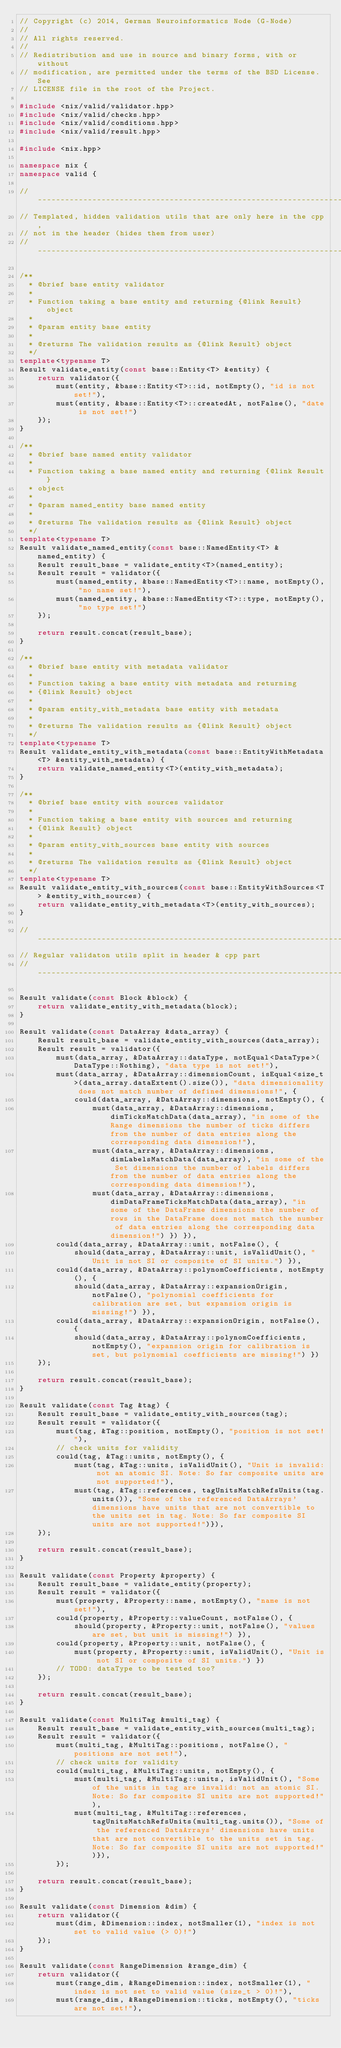Convert code to text. <code><loc_0><loc_0><loc_500><loc_500><_C++_>// Copyright (c) 2014, German Neuroinformatics Node (G-Node)
//
// All rights reserved.
//
// Redistribution and use in source and binary forms, with or without
// modification, are permitted under the terms of the BSD License. See
// LICENSE file in the root of the Project.

#include <nix/valid/validator.hpp>
#include <nix/valid/checks.hpp>
#include <nix/valid/conditions.hpp>
#include <nix/valid/result.hpp>

#include <nix.hpp>

namespace nix {
namespace valid {

// ---------------------------------------------------------------------
// Templated, hidden validation utils that are only here in the cpp,
// not in the header (hides them from user)
// ---------------------------------------------------------------------

/**
  * @brief base entity validator
  *
  * Function taking a base entity and returning {@link Result} object
  *
  * @param entity base entity
  *
  * @returns The validation results as {@link Result} object
  */
template<typename T>
Result validate_entity(const base::Entity<T> &entity) {
    return validator({
        must(entity, &base::Entity<T>::id, notEmpty(), "id is not set!"),
        must(entity, &base::Entity<T>::createdAt, notFalse(), "date is not set!")
    });
}

/**
  * @brief base named entity validator
  *
  * Function taking a base named entity and returning {@link Result}
  * object
  *
  * @param named_entity base named entity
  *
  * @returns The validation results as {@link Result} object
  */
template<typename T>
Result validate_named_entity(const base::NamedEntity<T> &named_entity) {
    Result result_base = validate_entity<T>(named_entity);
    Result result = validator({
        must(named_entity, &base::NamedEntity<T>::name, notEmpty(), "no name set!"),
        must(named_entity, &base::NamedEntity<T>::type, notEmpty(), "no type set!")
    });

    return result.concat(result_base);
}

/**
  * @brief base entity with metadata validator
  *
  * Function taking a base entity with metadata and returning
  * {@link Result} object
  *
  * @param entity_with_metadata base entity with metadata
  *
  * @returns The validation results as {@link Result} object
  */
template<typename T>
Result validate_entity_with_metadata(const base::EntityWithMetadata<T> &entity_with_metadata) {
    return validate_named_entity<T>(entity_with_metadata);
}

/**
  * @brief base entity with sources validator
  *
  * Function taking a base entity with sources and returning
  * {@link Result} object
  *
  * @param entity_with_sources base entity with sources
  *
  * @returns The validation results as {@link Result} object
  */
template<typename T>
Result validate_entity_with_sources(const base::EntityWithSources<T> &entity_with_sources) {
    return validate_entity_with_metadata<T>(entity_with_sources);
}

// ---------------------------------------------------------------------
// Regular validaton utils split in header & cpp part
// ---------------------------------------------------------------------

Result validate(const Block &block) {
    return validate_entity_with_metadata(block);
}

Result validate(const DataArray &data_array) {
    Result result_base = validate_entity_with_sources(data_array);
    Result result = validator({
        must(data_array, &DataArray::dataType, notEqual<DataType>(DataType::Nothing), "data type is not set!"),
        must(data_array, &DataArray::dimensionCount, isEqual<size_t>(data_array.dataExtent().size()), "data dimensionality does not match number of defined dimensions!", {
            could(data_array, &DataArray::dimensions, notEmpty(), {
                must(data_array, &DataArray::dimensions, dimTicksMatchData(data_array), "in some of the Range dimensions the number of ticks differs from the number of data entries along the corresponding data dimension!"),
                must(data_array, &DataArray::dimensions, dimLabelsMatchData(data_array), "in some of the Set dimensions the number of labels differs from the number of data entries along the corresponding data dimension!"),
                must(data_array, &DataArray::dimensions, dimDataFrameTicksMatchData(data_array), "in some of the DataFrame dimensions the number of rows in the DataFrame does not match the number of data entries along the corresponding data dimension!") }) }),
        could(data_array, &DataArray::unit, notFalse(), {
            should(data_array, &DataArray::unit, isValidUnit(), "Unit is not SI or composite of SI units.") }),
        could(data_array, &DataArray::polynomCoefficients, notEmpty(), {
            should(data_array, &DataArray::expansionOrigin, notFalse(), "polynomial coefficients for calibration are set, but expansion origin is missing!") }),
        could(data_array, &DataArray::expansionOrigin, notFalse(), {
            should(data_array, &DataArray::polynomCoefficients, notEmpty(), "expansion origin for calibration is set, but polynomial coefficients are missing!") })
    });

    return result.concat(result_base);
}

Result validate(const Tag &tag) {
    Result result_base = validate_entity_with_sources(tag);
    Result result = validator({
        must(tag, &Tag::position, notEmpty(), "position is not set!"),
        // check units for validity
        could(tag, &Tag::units, notEmpty(), {
            must(tag, &Tag::units, isValidUnit(), "Unit is invalid: not an atomic SI. Note: So far composite units are not supported!"),
            must(tag, &Tag::references, tagUnitsMatchRefsUnits(tag.units()), "Some of the referenced DataArrays' dimensions have units that are not convertible to the units set in tag. Note: So far composite SI units are not supported!")}),
    });

    return result.concat(result_base);
}

Result validate(const Property &property) {
    Result result_base = validate_entity(property);
    Result result = validator({
        must(property, &Property::name, notEmpty(), "name is not set!"),
        could(property, &Property::valueCount, notFalse(), {
            should(property, &Property::unit, notFalse(), "values are set, but unit is missing!") }),
        could(property, &Property::unit, notFalse(), {
            must(property, &Property::unit, isValidUnit(), "Unit is not SI or composite of SI units.") })
        // TODO: dataType to be tested too?
    });

    return result.concat(result_base);
}

Result validate(const MultiTag &multi_tag) {
    Result result_base = validate_entity_with_sources(multi_tag);
    Result result = validator({
        must(multi_tag, &MultiTag::positions, notFalse(), "positions are not set!"),
        // check units for validity
        could(multi_tag, &MultiTag::units, notEmpty(), {
            must(multi_tag, &MultiTag::units, isValidUnit(), "Some of the units in tag are invalid: not an atomic SI. Note: So far composite SI units are not supported!"),
            must(multi_tag, &MultiTag::references, tagUnitsMatchRefsUnits(multi_tag.units()), "Some of the referenced DataArrays' dimensions have units that are not convertible to the units set in tag. Note: So far composite SI units are not supported!")}),
        });

    return result.concat(result_base);
}

Result validate(const Dimension &dim) {
    return validator({
        must(dim, &Dimension::index, notSmaller(1), "index is not set to valid value (> 0)!")
    });
}

Result validate(const RangeDimension &range_dim) {
    return validator({
        must(range_dim, &RangeDimension::index, notSmaller(1), "index is not set to valid value (size_t > 0)!"),
        must(range_dim, &RangeDimension::ticks, notEmpty(), "ticks are not set!"),</code> 